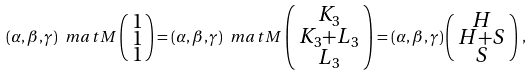<formula> <loc_0><loc_0><loc_500><loc_500>( \alpha , \beta , \gamma ) \ m a t { M } \left ( \, \begin{smallmatrix} 1 \\ 1 \\ 1 \end{smallmatrix} \right ) = ( \alpha , \beta , \gamma ) \ m a t { M } \left ( \, \begin{smallmatrix} K _ { 3 } \\ K _ { 3 } + L _ { 3 } \\ L _ { 3 } \end{smallmatrix} \, \right ) = ( \alpha , \beta , \gamma ) \left ( \, \begin{smallmatrix} H \\ H + S \\ S \end{smallmatrix} \, \right ) \, ,</formula> 